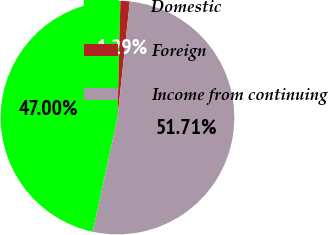Convert chart. <chart><loc_0><loc_0><loc_500><loc_500><pie_chart><fcel>Domestic<fcel>Foreign<fcel>Income from continuing<nl><fcel>47.0%<fcel>1.29%<fcel>51.71%<nl></chart> 